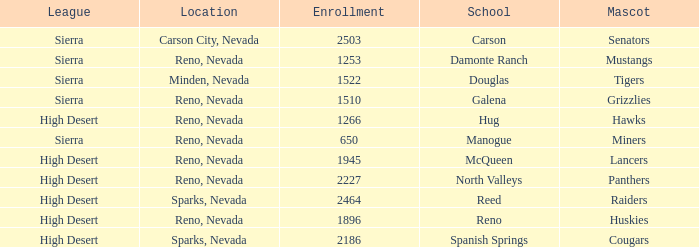What city and state is the Lancers mascot located? Reno, Nevada. 